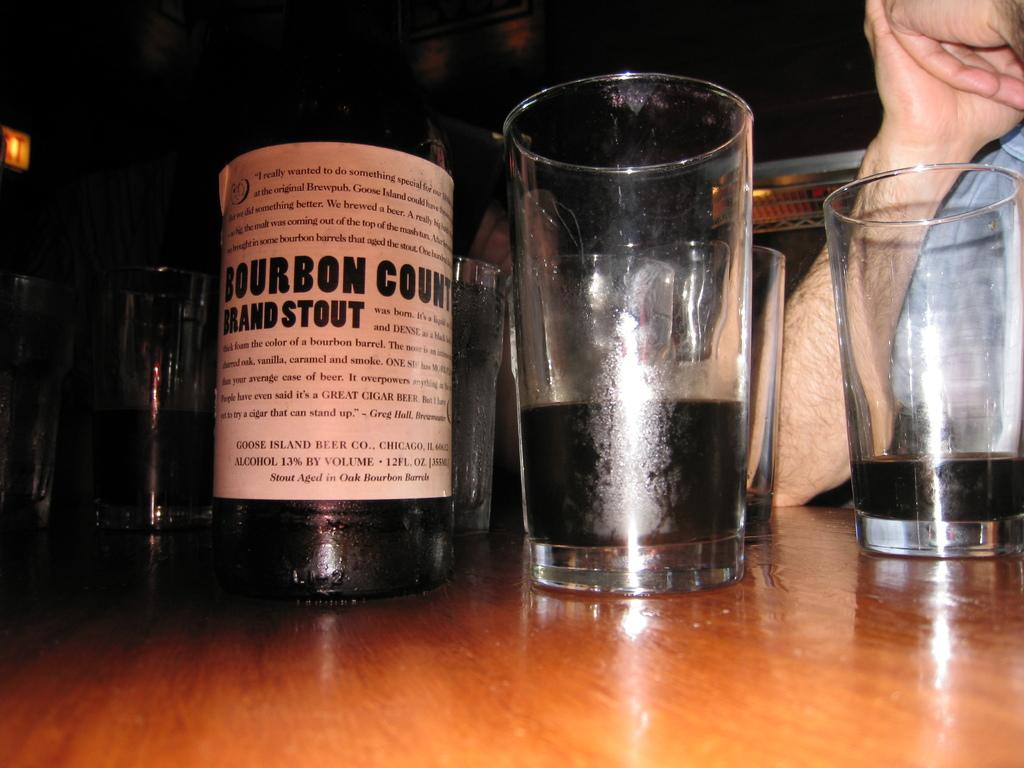<image>
Summarize the visual content of the image. A bottle of stout sits on a table among partially filled glasses. 